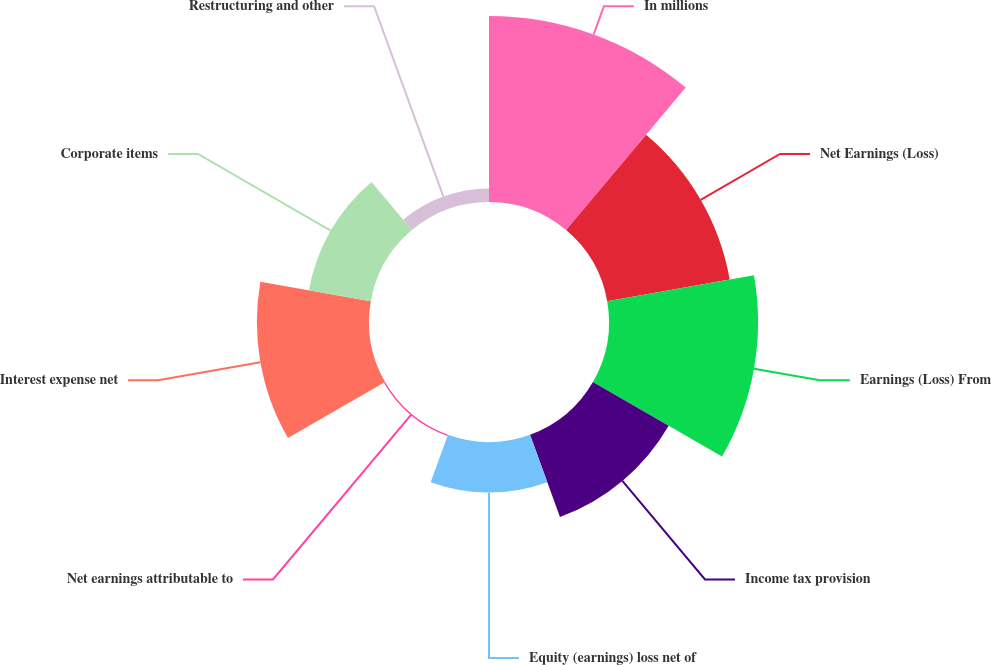Convert chart. <chart><loc_0><loc_0><loc_500><loc_500><pie_chart><fcel>In millions<fcel>Net Earnings (Loss)<fcel>Earnings (Loss) From<fcel>Income tax provision<fcel>Equity (earnings) loss net of<fcel>Net earnings attributable to<fcel>Interest expense net<fcel>Corporate items<fcel>Restructuring and other<nl><fcel>23.62%<fcel>15.8%<fcel>18.93%<fcel>11.11%<fcel>6.42%<fcel>0.17%<fcel>14.24%<fcel>7.98%<fcel>1.73%<nl></chart> 